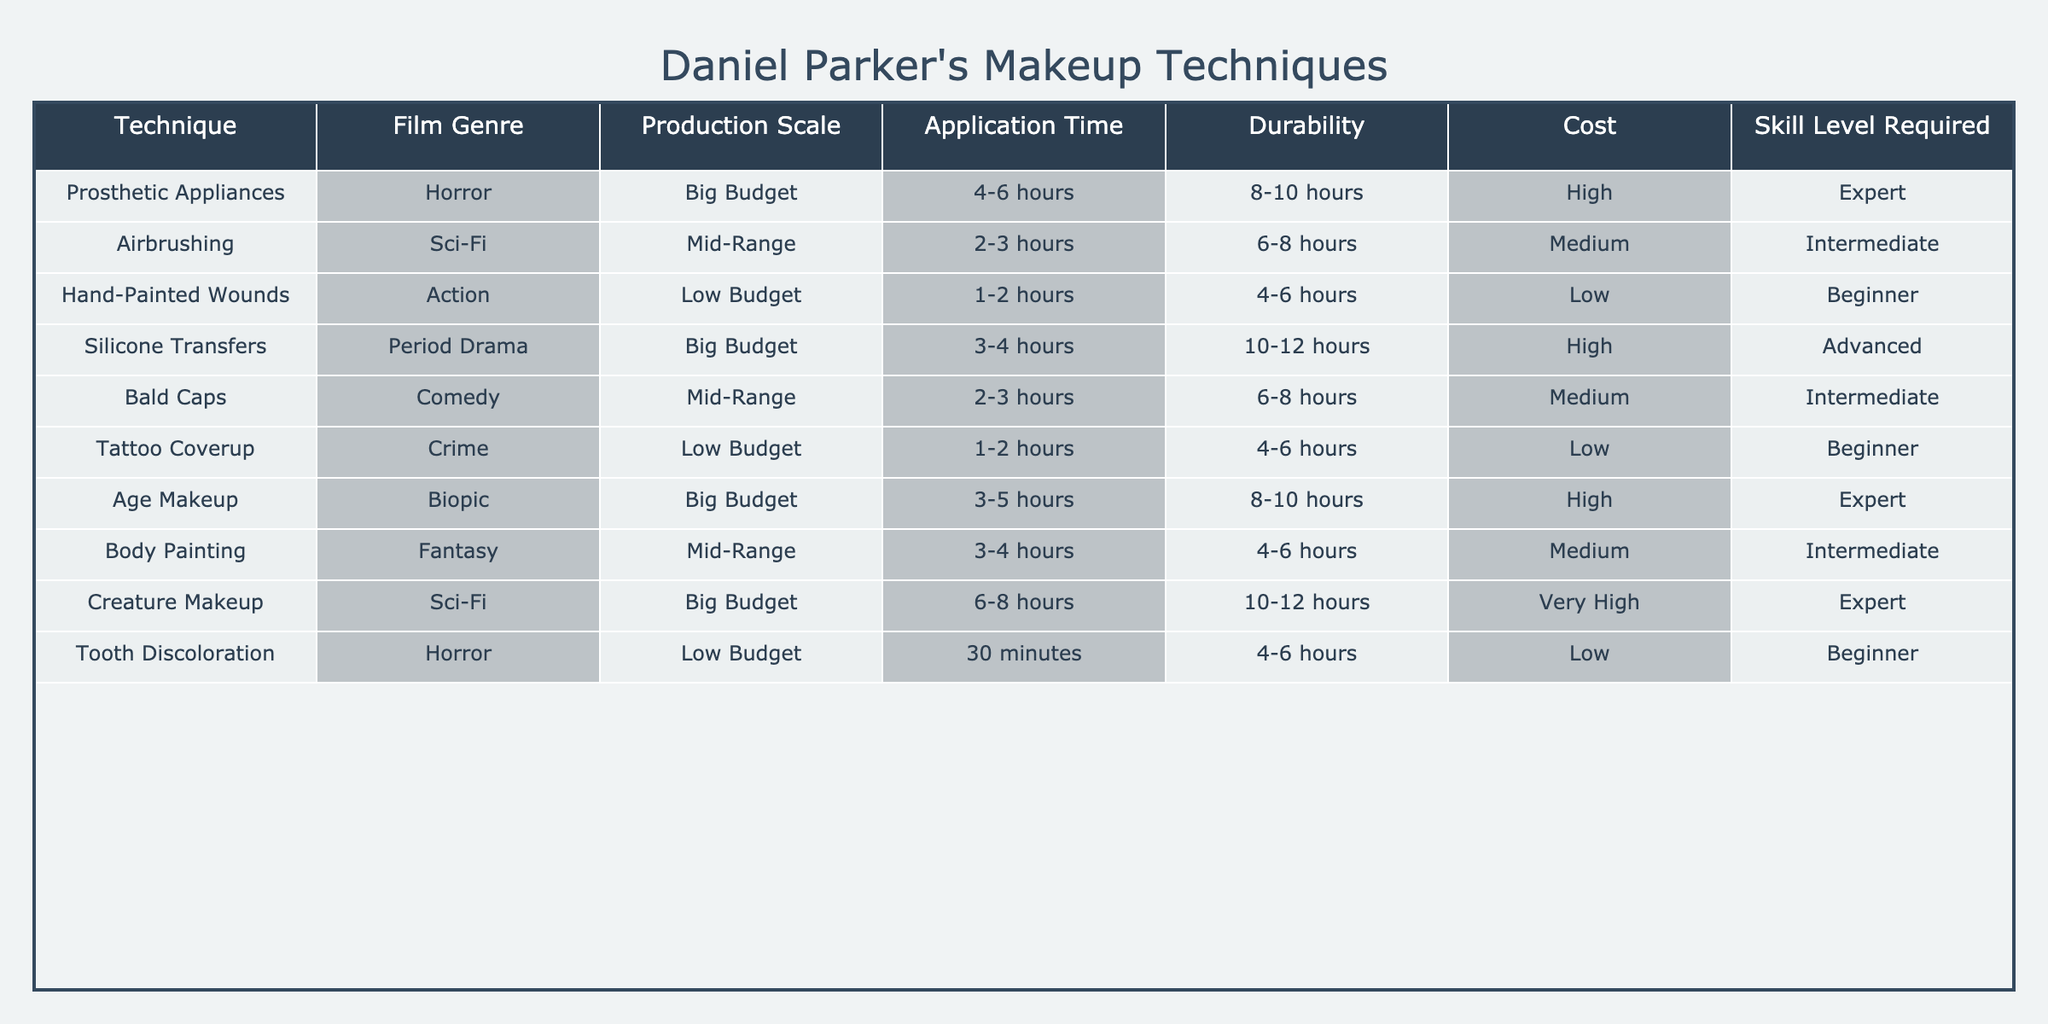What is the application time for the Creature Makeup technique? The table shows that Creature Makeup has an application time of 6-8 hours.
Answer: 6-8 hours Which technique has the highest cost? From the table, we can see that Creature Makeup and Prosthetic Appliances both have a "Very High" and "High" cost, respectively, but Creature Makeup is classified as "Very High", making it the highest.
Answer: Creature Makeup Is Airbrushing used in low budget films? According to the table, Airbrushing is listed under Sci-Fi with a Mid-Range production scale, so it is not used in low budget films.
Answer: No How many techniques have a skill level of 'Expert'? By counting the rows in the table, we find that there are three techniques with an expert skill level: Prosthetic Appliances, Age Makeup, and Creature Makeup.
Answer: 3 What is the average application time for techniques used in Big Budget films? The techniques for Big Budget films are Prosthetic Appliances (4-6 hours), Silicone Transfers (3-4 hours), and Age Makeup (3-5 hours). The average application time involves converting the ranges to a midpoint: (5 + 3.5 + 4) / 3 = 4.5 hours, so the average is approximately 4.5 hours.
Answer: 4.5 hours Which genres utilize techniques that require beginner skill levels? The table indicates that Hand-Painted Wounds (Action), Tattoo Coverup (Crime), and Tooth Discoloration (Horror) are used in genres that require beginner skill levels.
Answer: Action, Crime, Horror What is the durability time for the Body Painting technique? Looking at the table, Body Painting is shown to have a durability time of 4-6 hours.
Answer: 4-6 hours Does every technique for low budget films require a beginner skill level? The table indicates that while Hand-Painted Wounds and Tattoo Coverup require a beginner skill level, Tooth Discoloration is also included but takes only 30 minutes. Therefore, not every technique requires a beginner skill level, specifically in terms of film application time.
Answer: No How does the application time of Airbrushing compare to Hand-Painted Wounds? Airbrushing requires 2-3 hours and Hand-Painted Wounds only requires 1-2 hours, making Hand-Painted Wounds the quicker technique. The comparison shows Hand-Painted Wounds has less application time than Airbrushing.
Answer: Hand-Painted Wounds takes less time 